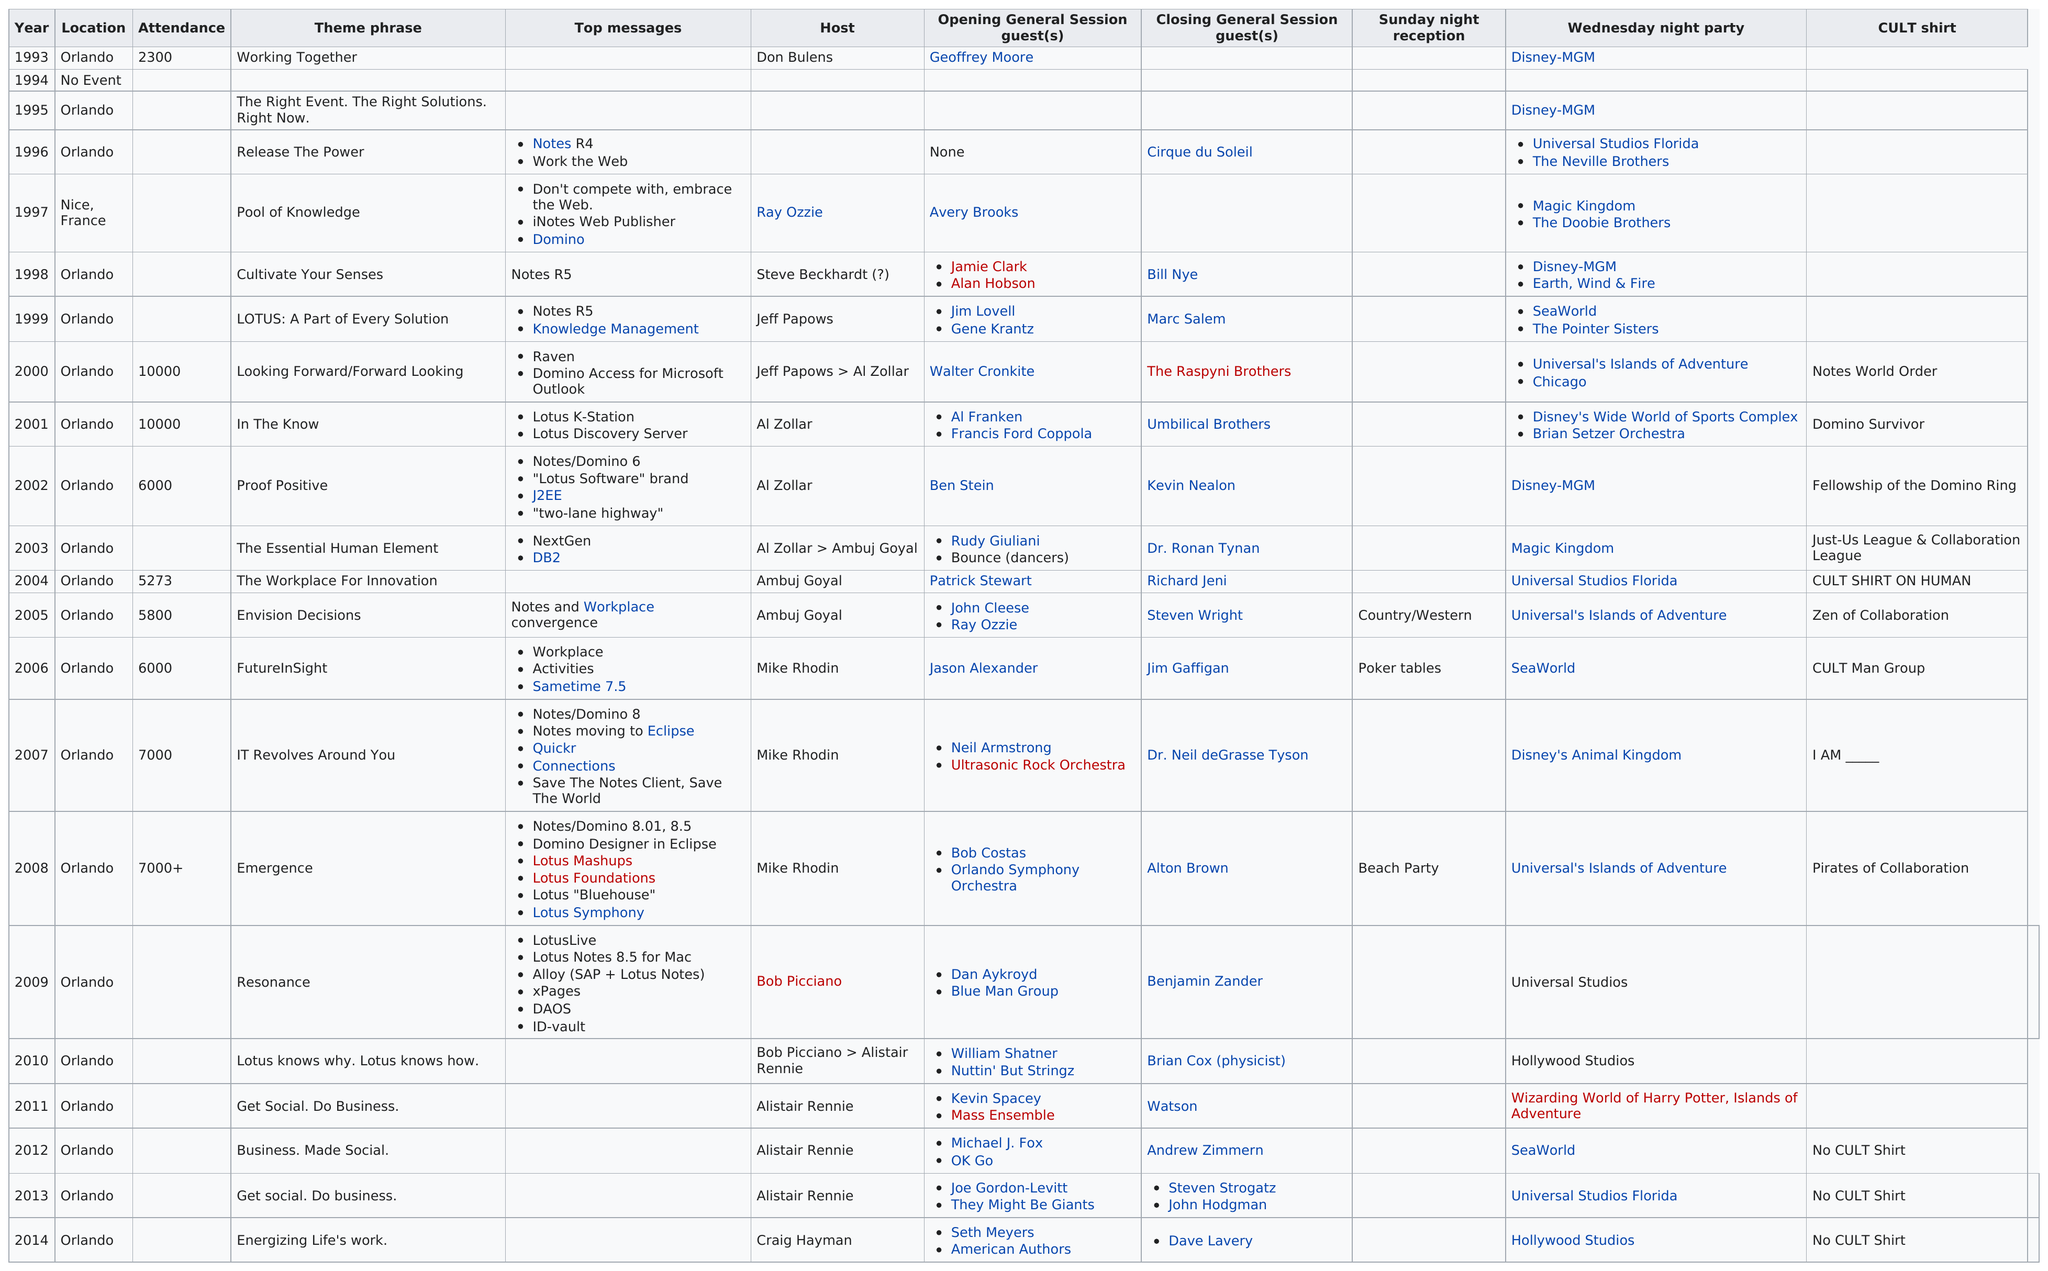Highlight a few significant elements in this photo. In 2006, Mike Rhodin was the host. In 1993, the attendance at the Lotusphere conference in Orlando was 2,300 people. The attendance at the Orlando Lotusphere conference in 2001 was higher than the one in 2004, with a difference of 4,727 people. In 1994, no event was held. In the year 2000, it is estimated that there were 10,000 people in attendance at the event. 